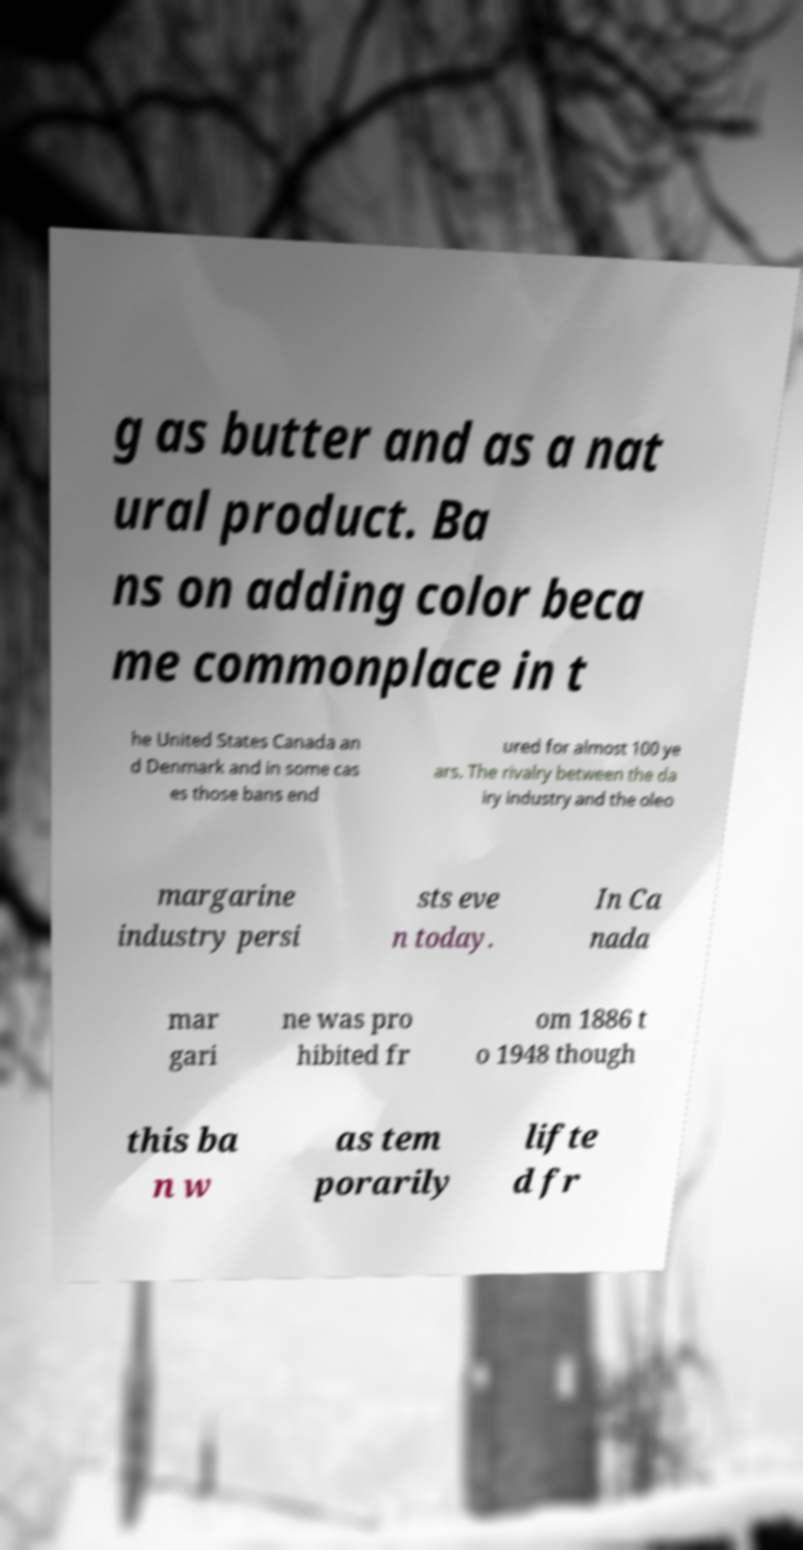Could you extract and type out the text from this image? g as butter and as a nat ural product. Ba ns on adding color beca me commonplace in t he United States Canada an d Denmark and in some cas es those bans end ured for almost 100 ye ars. The rivalry between the da iry industry and the oleo margarine industry persi sts eve n today. In Ca nada mar gari ne was pro hibited fr om 1886 t o 1948 though this ba n w as tem porarily lifte d fr 